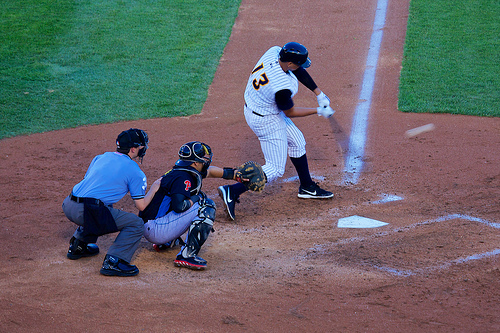Who is wearing a shoe? Both the umpire and the players are wearing shoes, each tailored to meet the demands of their roles on the field. 